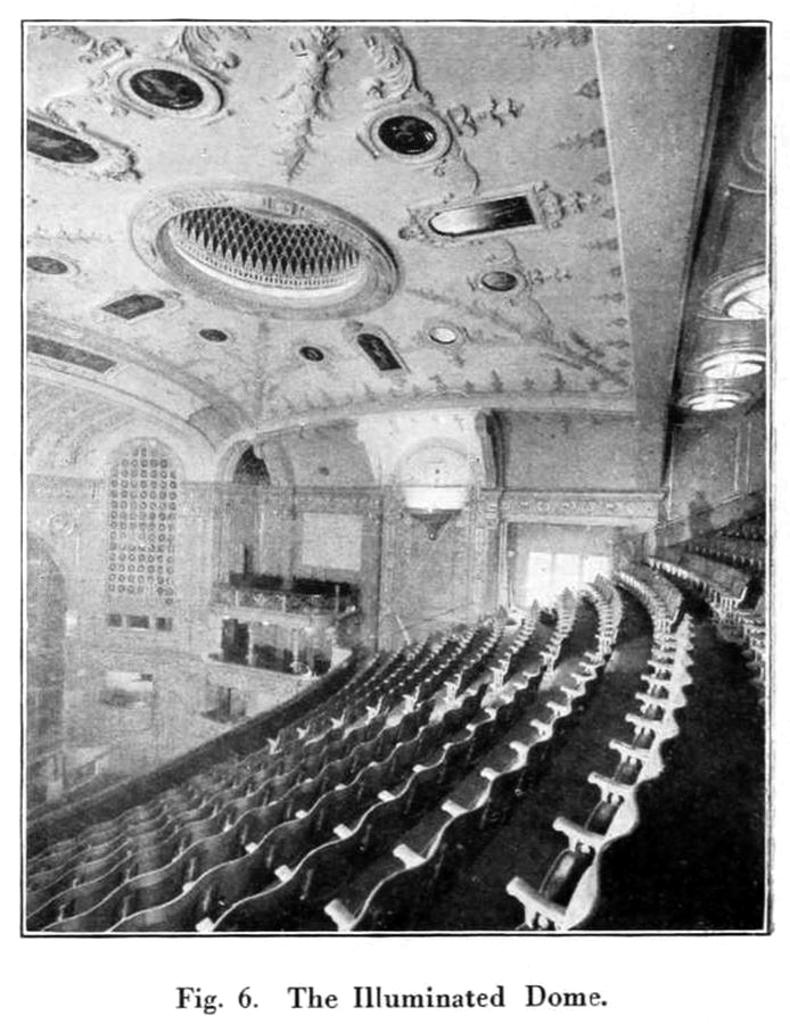What type of space is depicted in the image? There is a hall in the image. What can be found inside the hall? There are many chairs in the hall. Can you describe any architectural features of the hall? There is architecture on the roof of the hall. How many hands are visible on the chairs in the image? There are no hands visible on the chairs in the image. What type of sign is present in the hall in the image? There is no sign present in the hall in the image. 